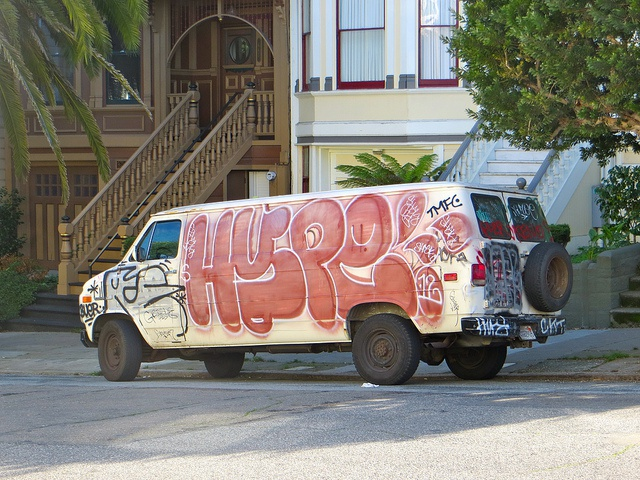Describe the objects in this image and their specific colors. I can see a truck in darkgreen, black, lightgray, lightpink, and salmon tones in this image. 